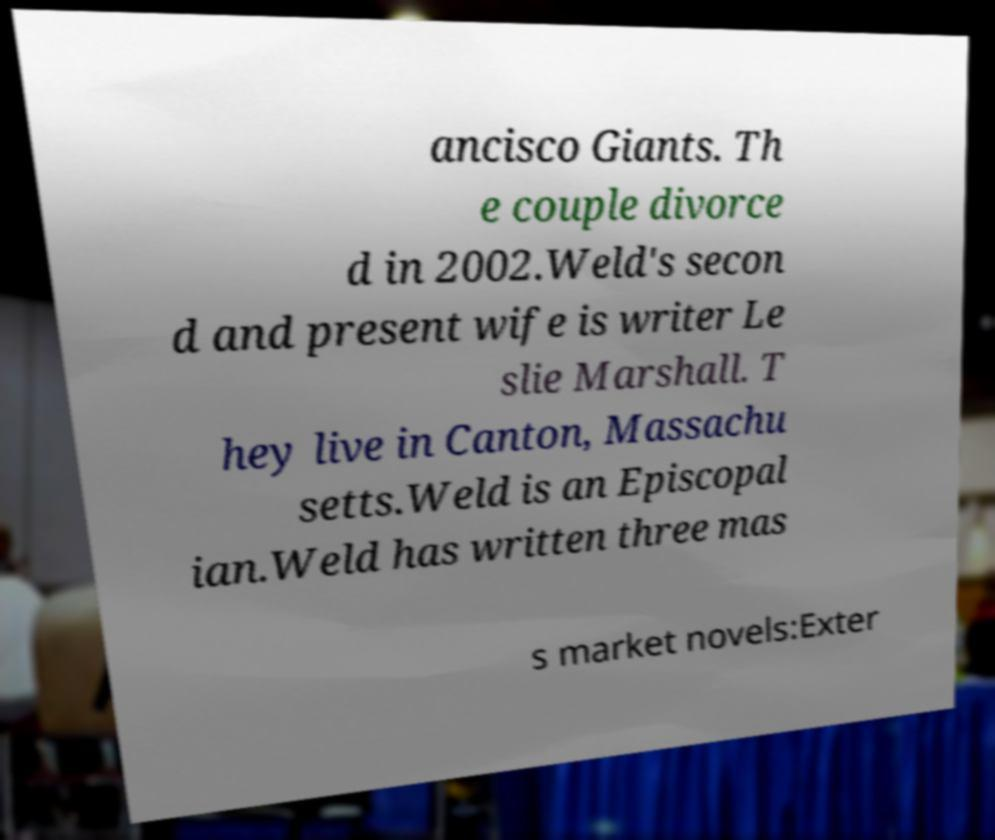Can you read and provide the text displayed in the image?This photo seems to have some interesting text. Can you extract and type it out for me? ancisco Giants. Th e couple divorce d in 2002.Weld's secon d and present wife is writer Le slie Marshall. T hey live in Canton, Massachu setts.Weld is an Episcopal ian.Weld has written three mas s market novels:Exter 